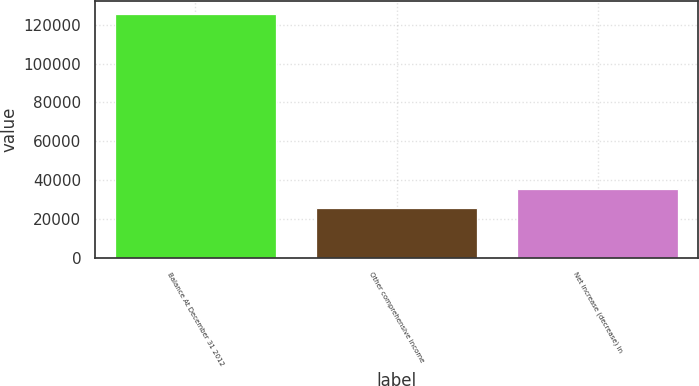Convert chart to OTSL. <chart><loc_0><loc_0><loc_500><loc_500><bar_chart><fcel>Balance At December 31 2012<fcel>Other comprehensive income<fcel>Net increase (decrease) in<nl><fcel>125661<fcel>25453<fcel>35473.8<nl></chart> 